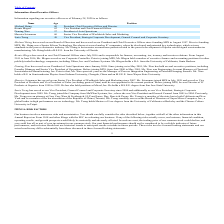According to Monolithic Power Systems's financial document, What is Michael Hsing's position in MPS? President and Chief Executive Officer. The document states: "d on our Board of Directors and has served as our President and Chief Executive Officer since founding MPS in August 1997. Prior to founding MPS, Mr. ..." Also, Where did Mr Xiao work just before joining MPS? Chartered Semiconductor Manufacturing, Inc.. The document states: "2001, Mr. Xiao was Engineering Account Manager at Chartered Semiconductor Manufacturing, Inc. Prior to that, Mr. Xiao spent six years as the Manager o..." Also, Which universities did Mr Hsing and Mr Blegen graduate from respectively? The document shows two values: University of Florida and University of California, Santa Barbara. From the document: "anufacturing. Mr. Hsing holds a B.S.E.E. from the University of Florida. Bernie Blegen has served as our Chief Financial Officer since July 2016 and i..." Also, can you calculate: What is the average age of the Executive Officers?  To answer this question, I need to perform calculations using the financial data. The calculation is: (60+62+57+60+49)/5, which equals 57.6. This is based on the information: "Bernie Blegen 62 Vice President and Chief Financial Officer Michael Hsing 60 President, Chief Executive Officer and Director Deming Xiao 57 President of Asia Operations Saria Tseng 49 Vice President, ..." The key data points involved are: 49, 60, 62. Also, can you calculate: For how many years has Mr Sciammas served as the company's Senior Vice President of Worldwide Sales and Marketing? Based on the calculation: 2020-2007, the result is 13. This is based on the information: "garding our executive officers as of February 28, 2020 is as follows: President of Worldwide Sales and Marketing since 2007. Mr. Sciammas joined MPS in July 1999 and served as Vice President of Produc..." The key data points involved are: 2007, 2020. Also, can you calculate: What is the collective number of years that Mr Xiao and Mr Sciammas have been working for at MPS? Based on the calculation: 2020-2001 + 2020-1999, the result is 40. This is based on the information: "garding our executive officers as of February 28, 2020 is as follows: tions since January 2008. Since joining us in May 2001, Mr. Xiao has held several executive positions, including Foundry Manager a..." The key data points involved are: 1999, 2001, 2020. 